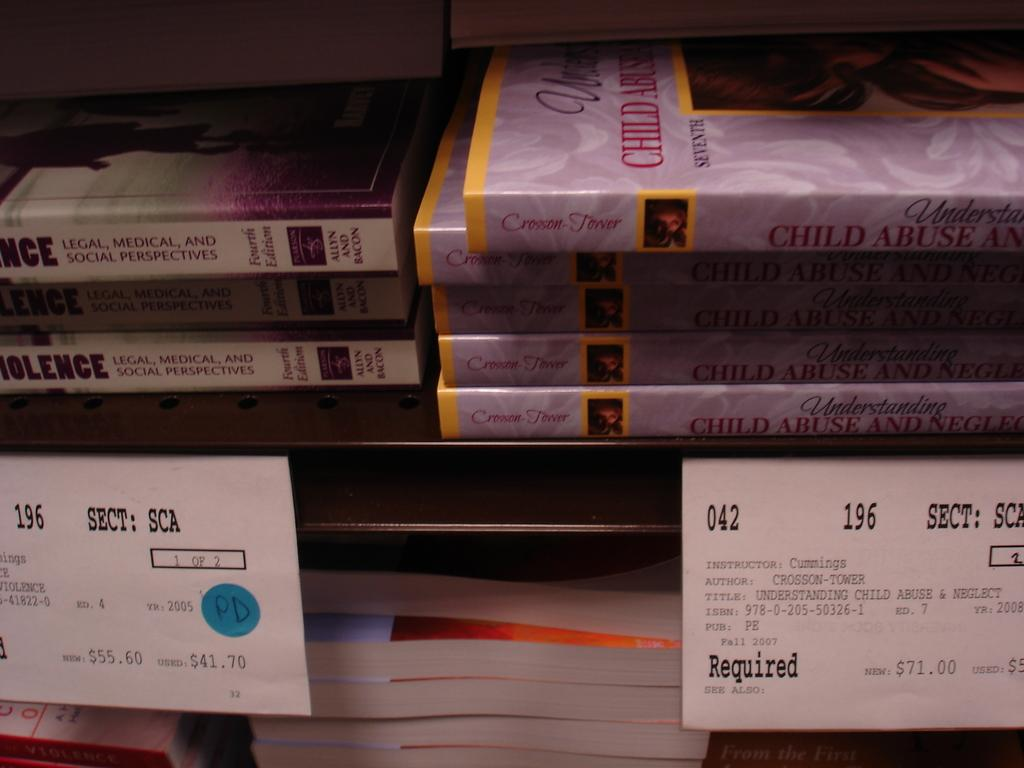<image>
Share a concise interpretation of the image provided. A shelf in a bookstore with text books including one about child abuse. 